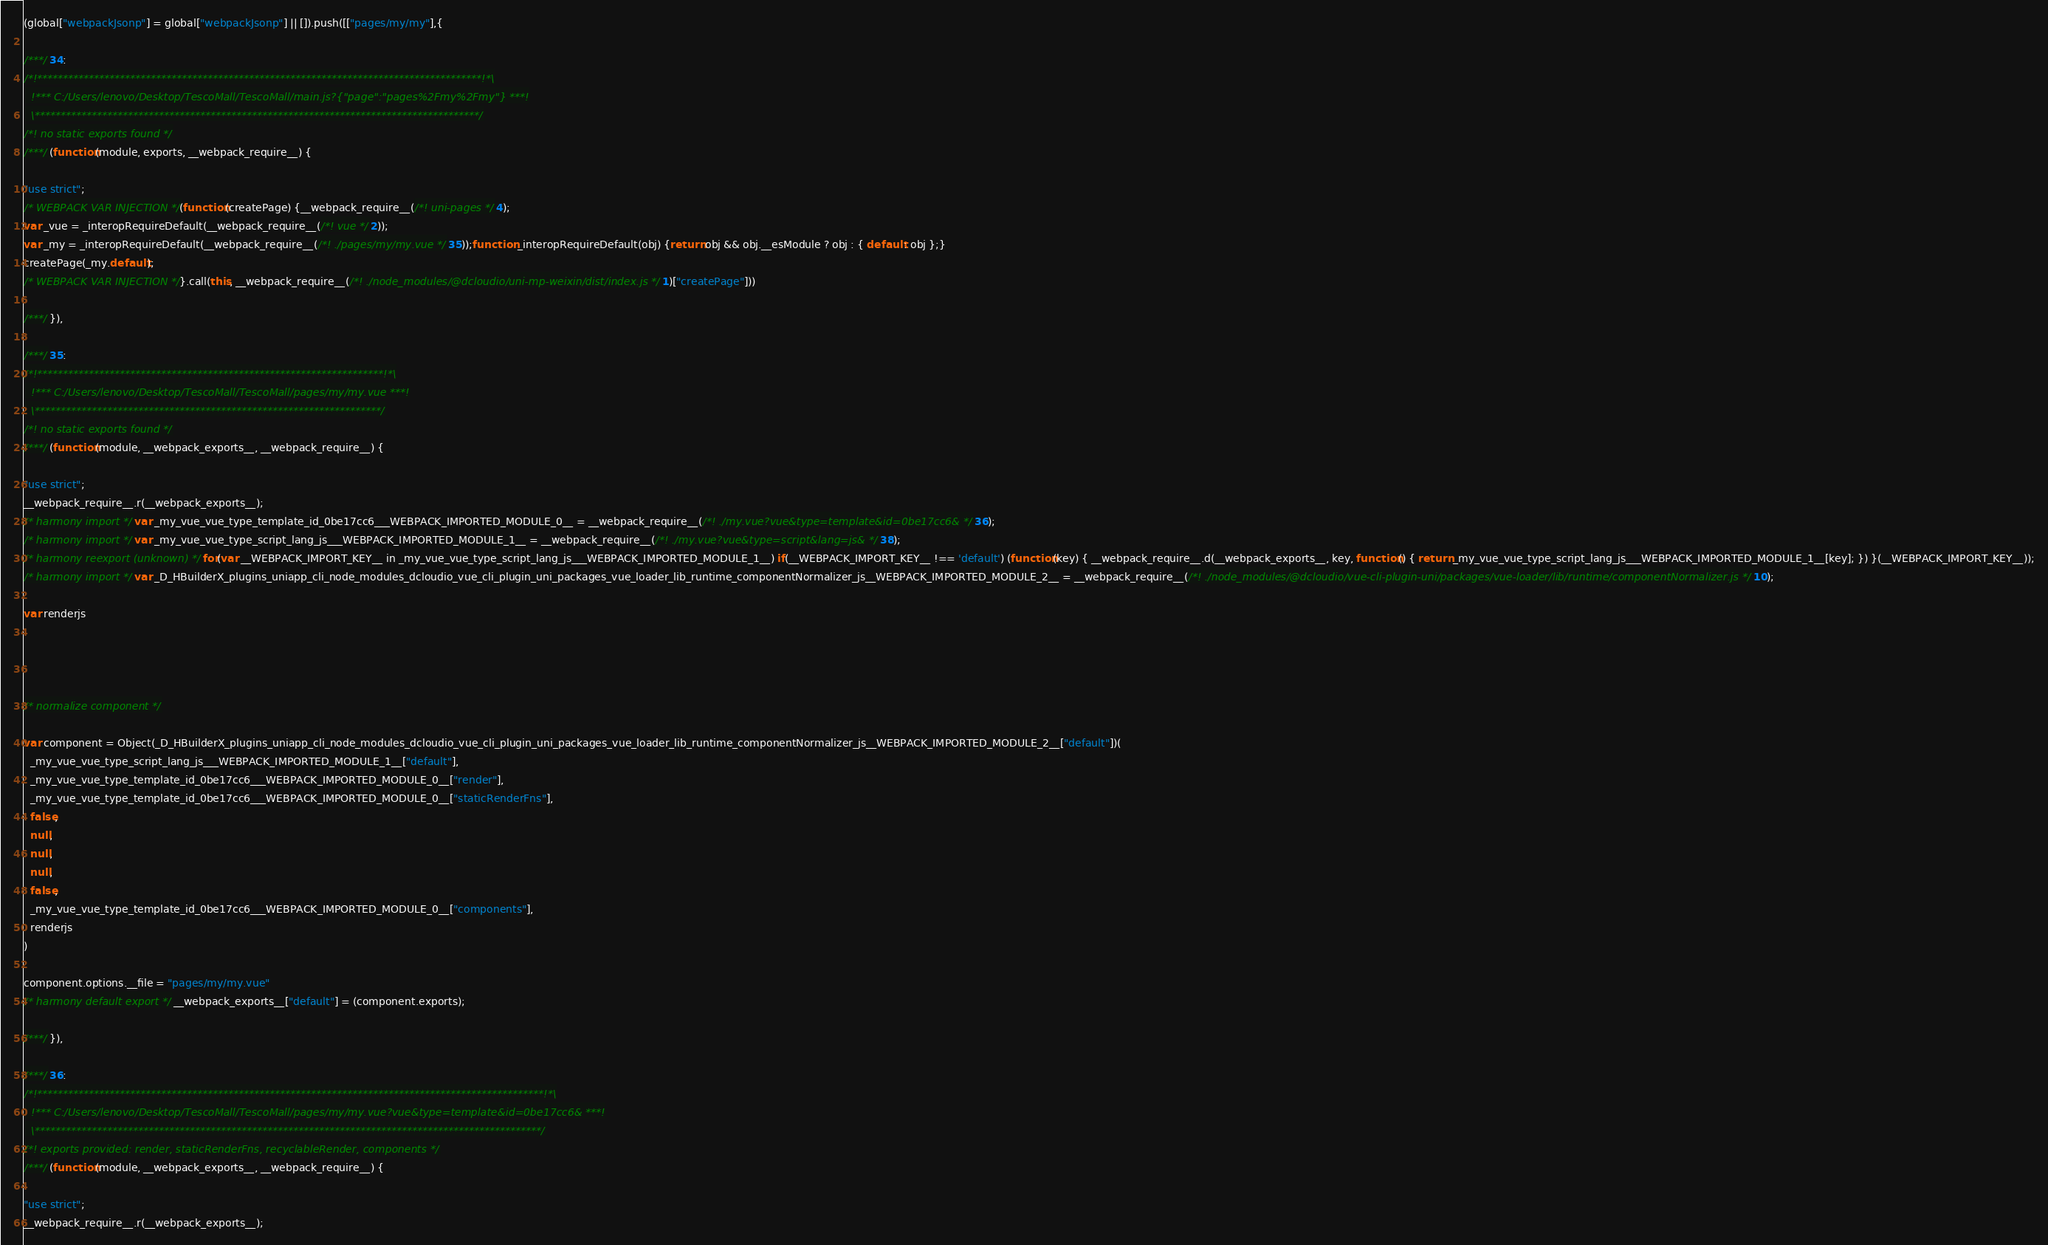<code> <loc_0><loc_0><loc_500><loc_500><_JavaScript_>(global["webpackJsonp"] = global["webpackJsonp"] || []).push([["pages/my/my"],{

/***/ 34:
/*!**************************************************************************************!*\
  !*** C:/Users/lenovo/Desktop/TescoMall/TescoMall/main.js?{"page":"pages%2Fmy%2Fmy"} ***!
  \**************************************************************************************/
/*! no static exports found */
/***/ (function(module, exports, __webpack_require__) {

"use strict";
/* WEBPACK VAR INJECTION */(function(createPage) {__webpack_require__(/*! uni-pages */ 4);
var _vue = _interopRequireDefault(__webpack_require__(/*! vue */ 2));
var _my = _interopRequireDefault(__webpack_require__(/*! ./pages/my/my.vue */ 35));function _interopRequireDefault(obj) {return obj && obj.__esModule ? obj : { default: obj };}
createPage(_my.default);
/* WEBPACK VAR INJECTION */}.call(this, __webpack_require__(/*! ./node_modules/@dcloudio/uni-mp-weixin/dist/index.js */ 1)["createPage"]))

/***/ }),

/***/ 35:
/*!*******************************************************************!*\
  !*** C:/Users/lenovo/Desktop/TescoMall/TescoMall/pages/my/my.vue ***!
  \*******************************************************************/
/*! no static exports found */
/***/ (function(module, __webpack_exports__, __webpack_require__) {

"use strict";
__webpack_require__.r(__webpack_exports__);
/* harmony import */ var _my_vue_vue_type_template_id_0be17cc6___WEBPACK_IMPORTED_MODULE_0__ = __webpack_require__(/*! ./my.vue?vue&type=template&id=0be17cc6& */ 36);
/* harmony import */ var _my_vue_vue_type_script_lang_js___WEBPACK_IMPORTED_MODULE_1__ = __webpack_require__(/*! ./my.vue?vue&type=script&lang=js& */ 38);
/* harmony reexport (unknown) */ for(var __WEBPACK_IMPORT_KEY__ in _my_vue_vue_type_script_lang_js___WEBPACK_IMPORTED_MODULE_1__) if(__WEBPACK_IMPORT_KEY__ !== 'default') (function(key) { __webpack_require__.d(__webpack_exports__, key, function() { return _my_vue_vue_type_script_lang_js___WEBPACK_IMPORTED_MODULE_1__[key]; }) }(__WEBPACK_IMPORT_KEY__));
/* harmony import */ var _D_HBuilderX_plugins_uniapp_cli_node_modules_dcloudio_vue_cli_plugin_uni_packages_vue_loader_lib_runtime_componentNormalizer_js__WEBPACK_IMPORTED_MODULE_2__ = __webpack_require__(/*! ./node_modules/@dcloudio/vue-cli-plugin-uni/packages/vue-loader/lib/runtime/componentNormalizer.js */ 10);

var renderjs




/* normalize component */

var component = Object(_D_HBuilderX_plugins_uniapp_cli_node_modules_dcloudio_vue_cli_plugin_uni_packages_vue_loader_lib_runtime_componentNormalizer_js__WEBPACK_IMPORTED_MODULE_2__["default"])(
  _my_vue_vue_type_script_lang_js___WEBPACK_IMPORTED_MODULE_1__["default"],
  _my_vue_vue_type_template_id_0be17cc6___WEBPACK_IMPORTED_MODULE_0__["render"],
  _my_vue_vue_type_template_id_0be17cc6___WEBPACK_IMPORTED_MODULE_0__["staticRenderFns"],
  false,
  null,
  null,
  null,
  false,
  _my_vue_vue_type_template_id_0be17cc6___WEBPACK_IMPORTED_MODULE_0__["components"],
  renderjs
)

component.options.__file = "pages/my/my.vue"
/* harmony default export */ __webpack_exports__["default"] = (component.exports);

/***/ }),

/***/ 36:
/*!**************************************************************************************************!*\
  !*** C:/Users/lenovo/Desktop/TescoMall/TescoMall/pages/my/my.vue?vue&type=template&id=0be17cc6& ***!
  \**************************************************************************************************/
/*! exports provided: render, staticRenderFns, recyclableRender, components */
/***/ (function(module, __webpack_exports__, __webpack_require__) {

"use strict";
__webpack_require__.r(__webpack_exports__);</code> 